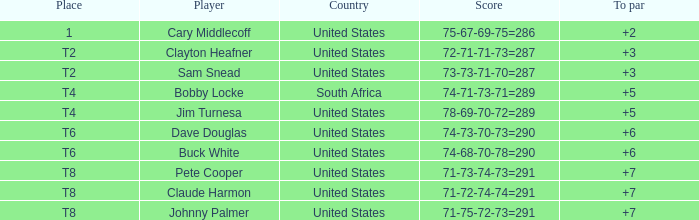What is Claude Harmon's Place? T8. 